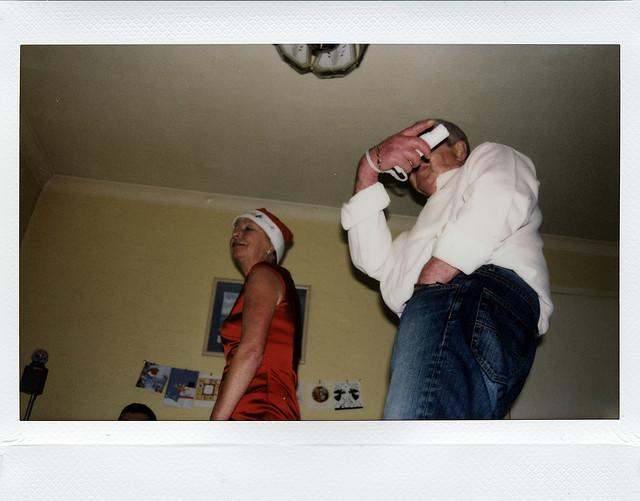What is the woman wearing on her head?

Choices:
A) baseball cap
B) bandana
C) straw hat
D) headband headband 